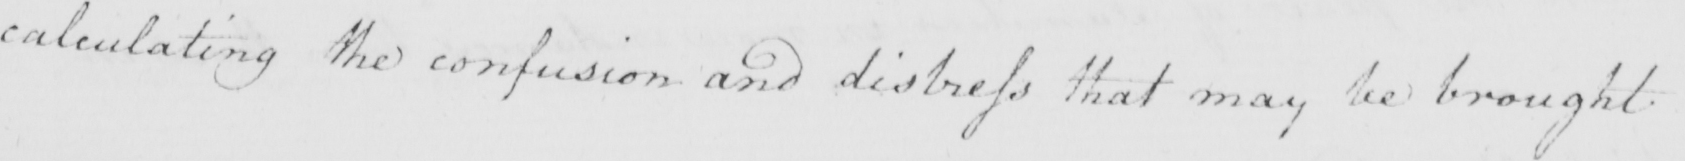What text is written in this handwritten line? calculating the confusion and distress that may be brought 